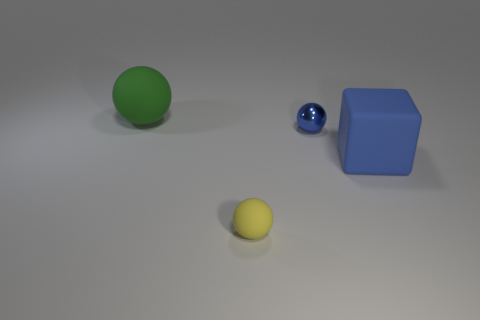What materials are the other objects made of? The yellow object appears to be a small, matte sphere, potentially made of a material like plastic or ceramic, while the blue object has the shape and sheen of a cube, suggesting it could be made of plastic, metal, or painted wood. Lastly, the small blue sphere has a reflective surface that resembles glass or a polished, metallic finish. 